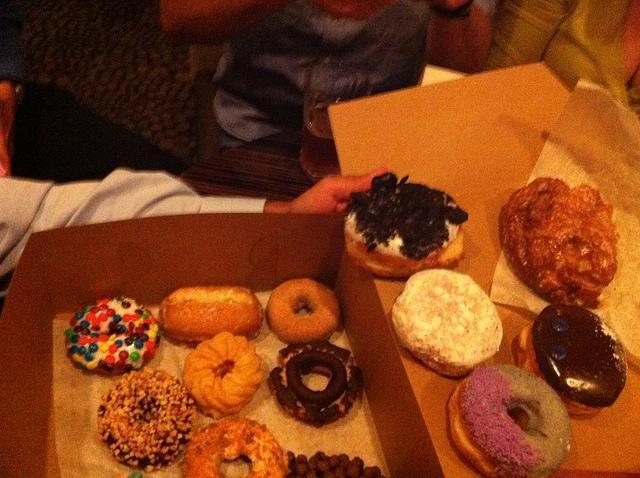How many people are there?
Give a very brief answer. 2. How many donuts are there?
Give a very brief answer. 12. How many dogs are on the bus?
Give a very brief answer. 0. 